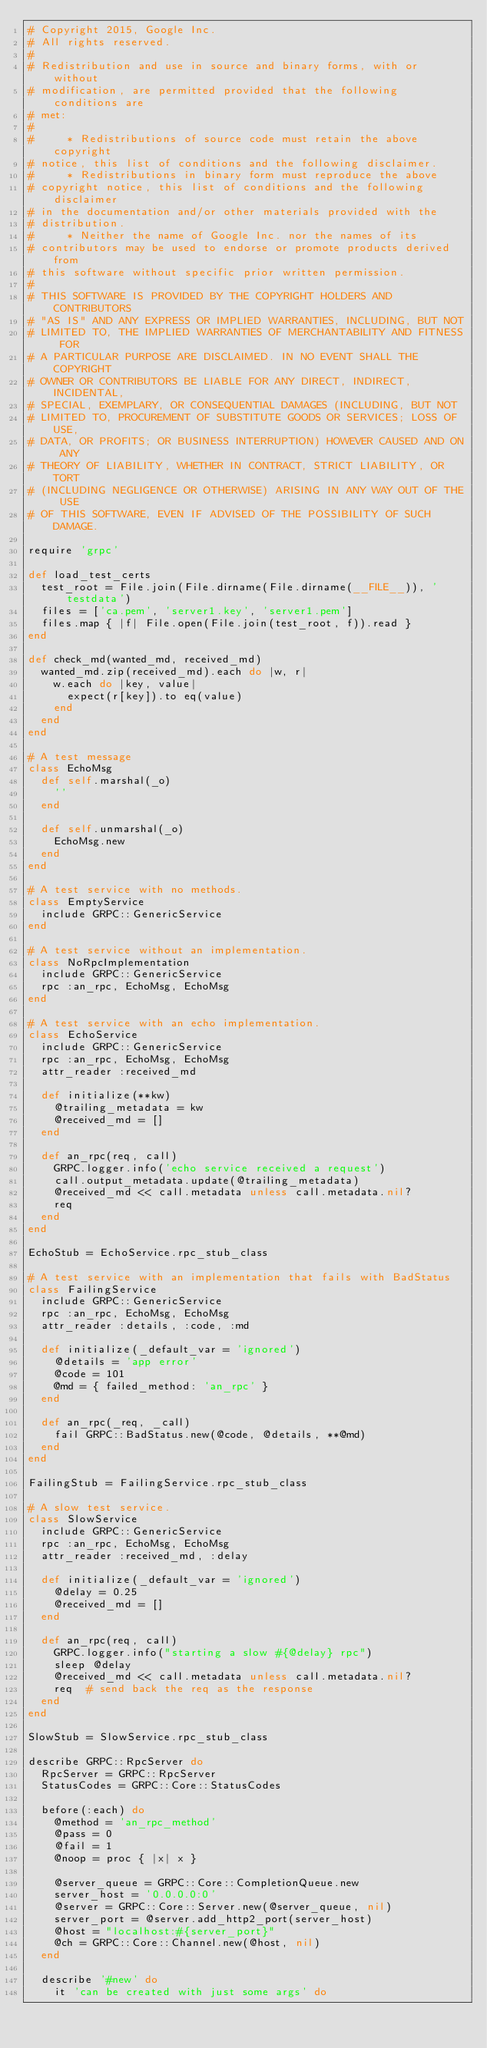Convert code to text. <code><loc_0><loc_0><loc_500><loc_500><_Ruby_># Copyright 2015, Google Inc.
# All rights reserved.
#
# Redistribution and use in source and binary forms, with or without
# modification, are permitted provided that the following conditions are
# met:
#
#     * Redistributions of source code must retain the above copyright
# notice, this list of conditions and the following disclaimer.
#     * Redistributions in binary form must reproduce the above
# copyright notice, this list of conditions and the following disclaimer
# in the documentation and/or other materials provided with the
# distribution.
#     * Neither the name of Google Inc. nor the names of its
# contributors may be used to endorse or promote products derived from
# this software without specific prior written permission.
#
# THIS SOFTWARE IS PROVIDED BY THE COPYRIGHT HOLDERS AND CONTRIBUTORS
# "AS IS" AND ANY EXPRESS OR IMPLIED WARRANTIES, INCLUDING, BUT NOT
# LIMITED TO, THE IMPLIED WARRANTIES OF MERCHANTABILITY AND FITNESS FOR
# A PARTICULAR PURPOSE ARE DISCLAIMED. IN NO EVENT SHALL THE COPYRIGHT
# OWNER OR CONTRIBUTORS BE LIABLE FOR ANY DIRECT, INDIRECT, INCIDENTAL,
# SPECIAL, EXEMPLARY, OR CONSEQUENTIAL DAMAGES (INCLUDING, BUT NOT
# LIMITED TO, PROCUREMENT OF SUBSTITUTE GOODS OR SERVICES; LOSS OF USE,
# DATA, OR PROFITS; OR BUSINESS INTERRUPTION) HOWEVER CAUSED AND ON ANY
# THEORY OF LIABILITY, WHETHER IN CONTRACT, STRICT LIABILITY, OR TORT
# (INCLUDING NEGLIGENCE OR OTHERWISE) ARISING IN ANY WAY OUT OF THE USE
# OF THIS SOFTWARE, EVEN IF ADVISED OF THE POSSIBILITY OF SUCH DAMAGE.

require 'grpc'

def load_test_certs
  test_root = File.join(File.dirname(File.dirname(__FILE__)), 'testdata')
  files = ['ca.pem', 'server1.key', 'server1.pem']
  files.map { |f| File.open(File.join(test_root, f)).read }
end

def check_md(wanted_md, received_md)
  wanted_md.zip(received_md).each do |w, r|
    w.each do |key, value|
      expect(r[key]).to eq(value)
    end
  end
end

# A test message
class EchoMsg
  def self.marshal(_o)
    ''
  end

  def self.unmarshal(_o)
    EchoMsg.new
  end
end

# A test service with no methods.
class EmptyService
  include GRPC::GenericService
end

# A test service without an implementation.
class NoRpcImplementation
  include GRPC::GenericService
  rpc :an_rpc, EchoMsg, EchoMsg
end

# A test service with an echo implementation.
class EchoService
  include GRPC::GenericService
  rpc :an_rpc, EchoMsg, EchoMsg
  attr_reader :received_md

  def initialize(**kw)
    @trailing_metadata = kw
    @received_md = []
  end

  def an_rpc(req, call)
    GRPC.logger.info('echo service received a request')
    call.output_metadata.update(@trailing_metadata)
    @received_md << call.metadata unless call.metadata.nil?
    req
  end
end

EchoStub = EchoService.rpc_stub_class

# A test service with an implementation that fails with BadStatus
class FailingService
  include GRPC::GenericService
  rpc :an_rpc, EchoMsg, EchoMsg
  attr_reader :details, :code, :md

  def initialize(_default_var = 'ignored')
    @details = 'app error'
    @code = 101
    @md = { failed_method: 'an_rpc' }
  end

  def an_rpc(_req, _call)
    fail GRPC::BadStatus.new(@code, @details, **@md)
  end
end

FailingStub = FailingService.rpc_stub_class

# A slow test service.
class SlowService
  include GRPC::GenericService
  rpc :an_rpc, EchoMsg, EchoMsg
  attr_reader :received_md, :delay

  def initialize(_default_var = 'ignored')
    @delay = 0.25
    @received_md = []
  end

  def an_rpc(req, call)
    GRPC.logger.info("starting a slow #{@delay} rpc")
    sleep @delay
    @received_md << call.metadata unless call.metadata.nil?
    req  # send back the req as the response
  end
end

SlowStub = SlowService.rpc_stub_class

describe GRPC::RpcServer do
  RpcServer = GRPC::RpcServer
  StatusCodes = GRPC::Core::StatusCodes

  before(:each) do
    @method = 'an_rpc_method'
    @pass = 0
    @fail = 1
    @noop = proc { |x| x }

    @server_queue = GRPC::Core::CompletionQueue.new
    server_host = '0.0.0.0:0'
    @server = GRPC::Core::Server.new(@server_queue, nil)
    server_port = @server.add_http2_port(server_host)
    @host = "localhost:#{server_port}"
    @ch = GRPC::Core::Channel.new(@host, nil)
  end

  describe '#new' do
    it 'can be created with just some args' do</code> 